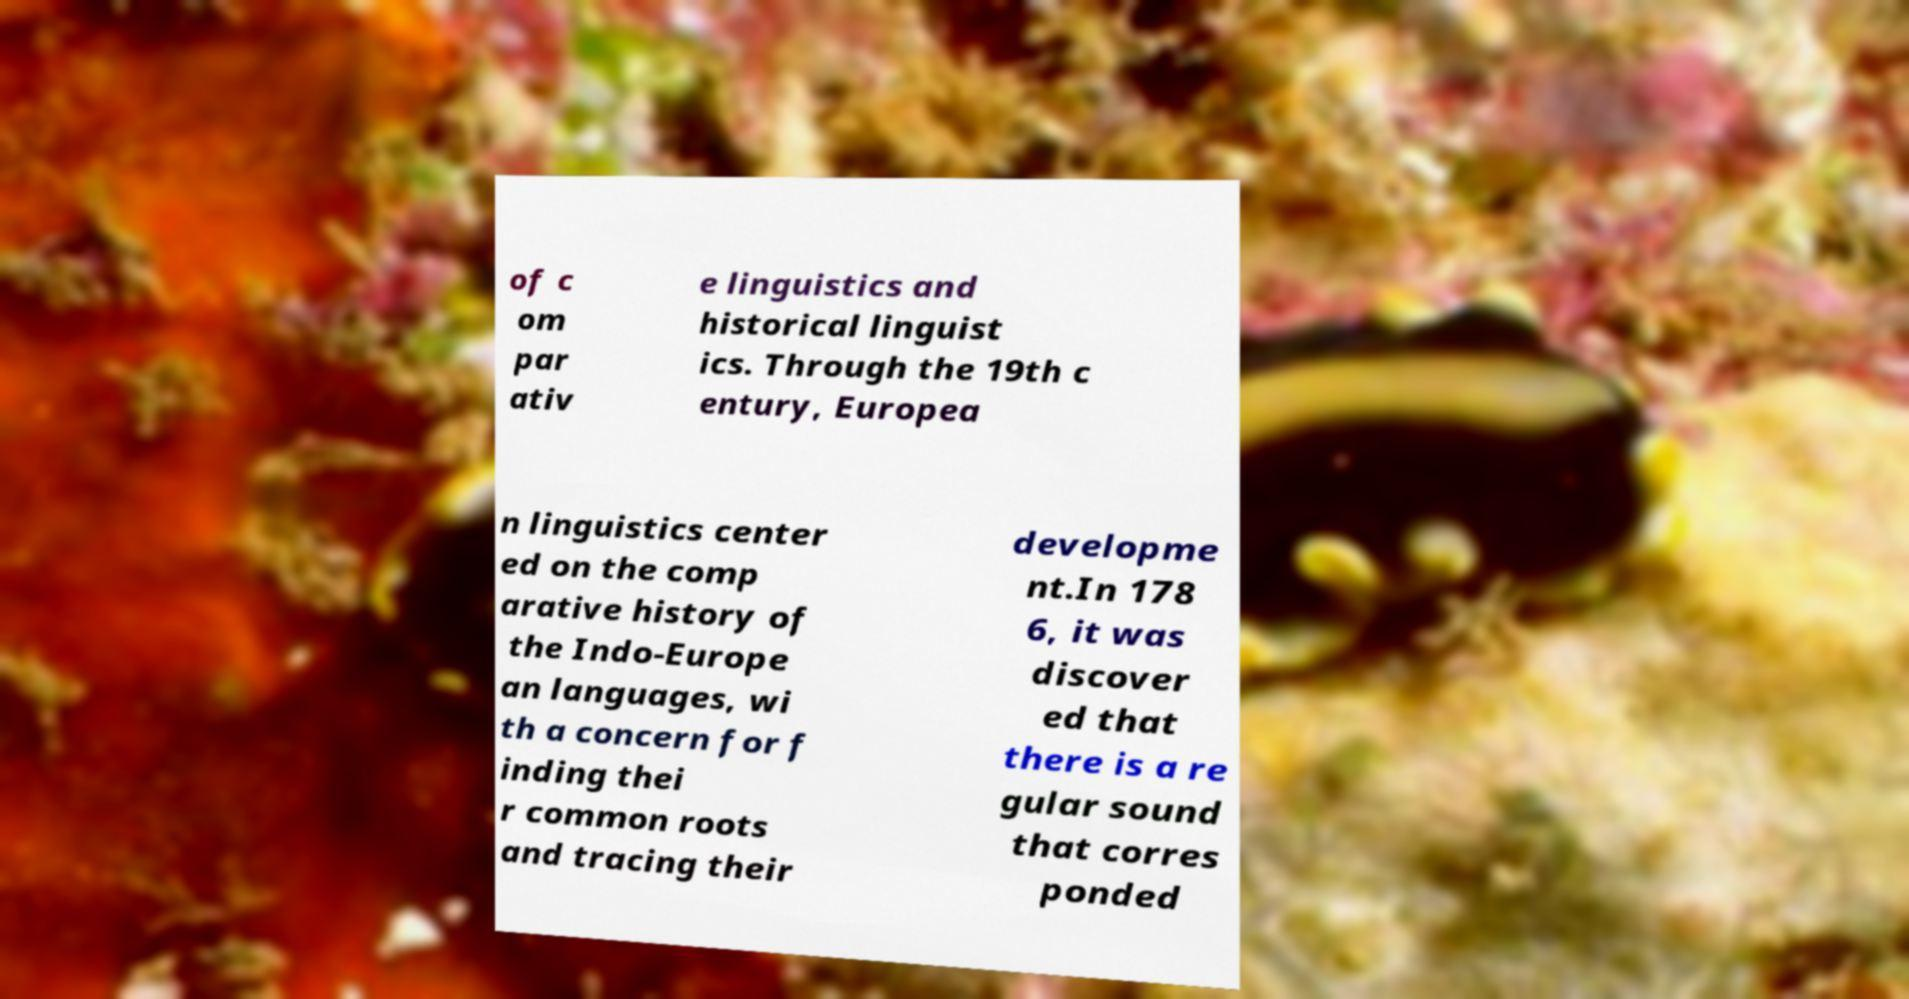There's text embedded in this image that I need extracted. Can you transcribe it verbatim? of c om par ativ e linguistics and historical linguist ics. Through the 19th c entury, Europea n linguistics center ed on the comp arative history of the Indo-Europe an languages, wi th a concern for f inding thei r common roots and tracing their developme nt.In 178 6, it was discover ed that there is a re gular sound that corres ponded 